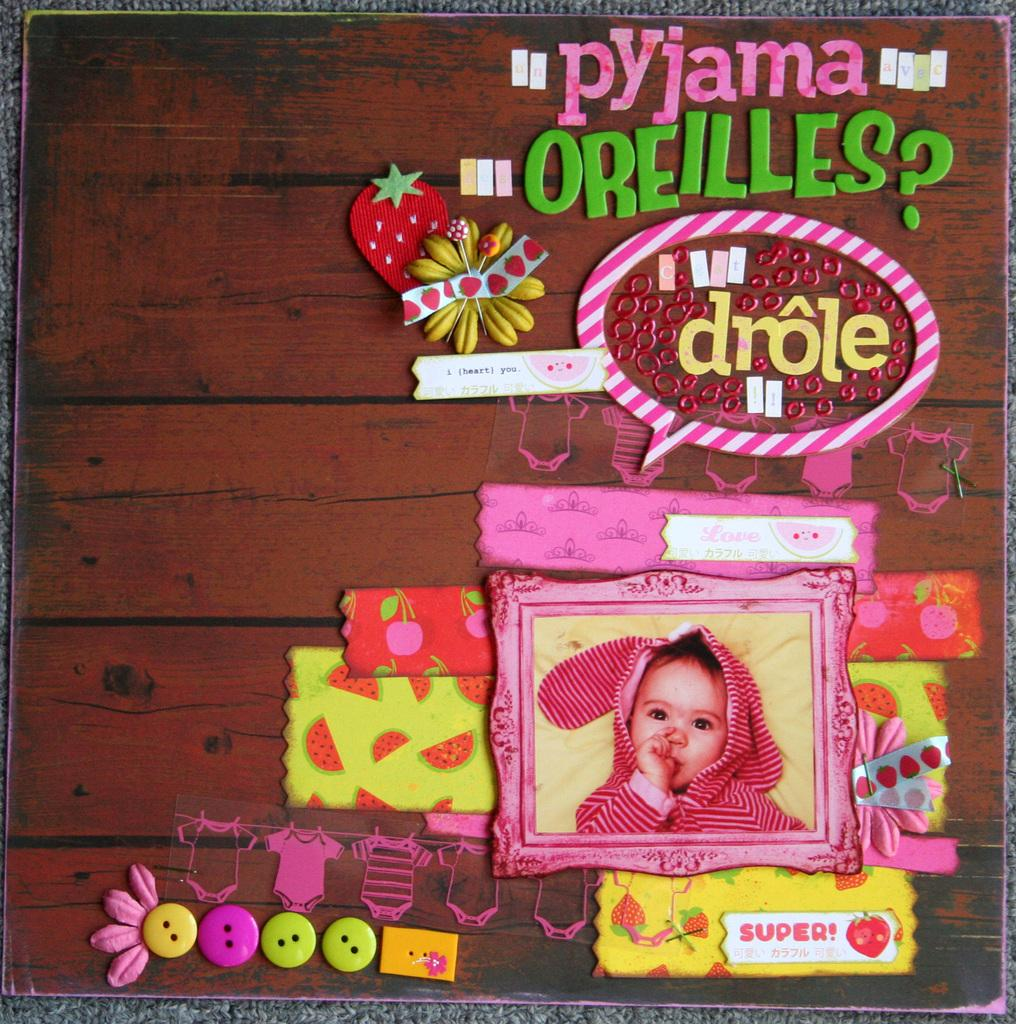What object in the image is typically used for displaying photos? There is a photo frame in the image. What type of material is present in the image? There is a cloth in the image. What can be found written or printed in the image? There is some text in the image. What type of fastener is visible in the image? There are clips in the image. How many bikes are stored in the image? There are no bikes present in the image. What type of fruit is placed inside the drawer in the image? There is no drawer or fruit present in the image. 